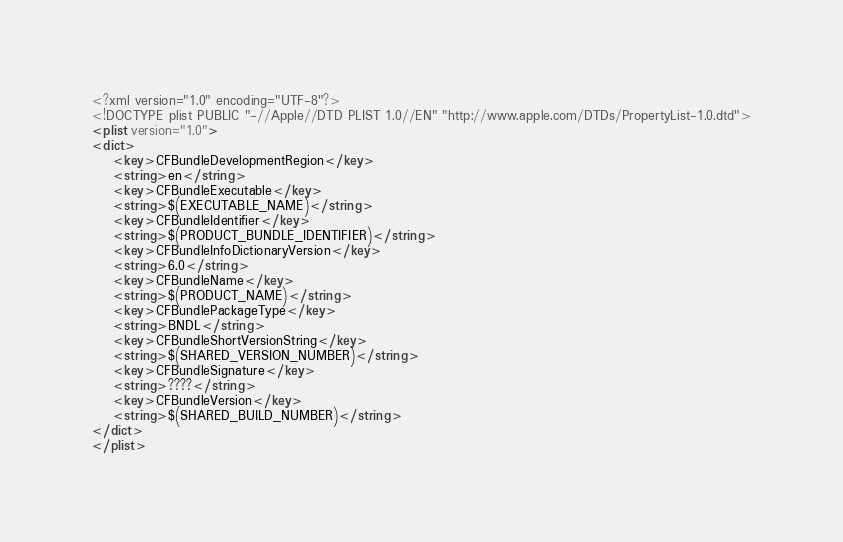Convert code to text. <code><loc_0><loc_0><loc_500><loc_500><_XML_><?xml version="1.0" encoding="UTF-8"?>
<!DOCTYPE plist PUBLIC "-//Apple//DTD PLIST 1.0//EN" "http://www.apple.com/DTDs/PropertyList-1.0.dtd">
<plist version="1.0">
<dict>
	<key>CFBundleDevelopmentRegion</key>
	<string>en</string>
	<key>CFBundleExecutable</key>
	<string>$(EXECUTABLE_NAME)</string>
	<key>CFBundleIdentifier</key>
	<string>$(PRODUCT_BUNDLE_IDENTIFIER)</string>
	<key>CFBundleInfoDictionaryVersion</key>
	<string>6.0</string>
	<key>CFBundleName</key>
	<string>$(PRODUCT_NAME)</string>
	<key>CFBundlePackageType</key>
	<string>BNDL</string>
	<key>CFBundleShortVersionString</key>
	<string>$(SHARED_VERSION_NUMBER)</string>
	<key>CFBundleSignature</key>
	<string>????</string>
	<key>CFBundleVersion</key>
	<string>$(SHARED_BUILD_NUMBER)</string>
</dict>
</plist>
</code> 